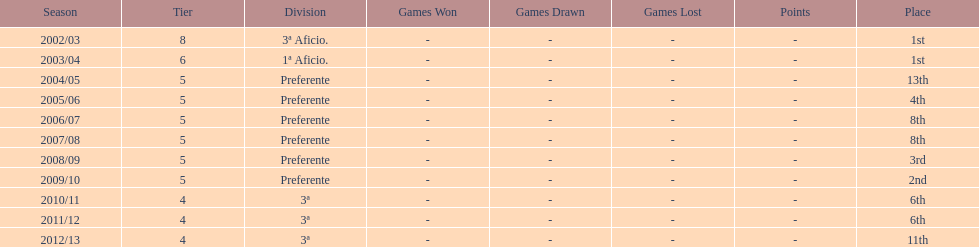Which division has the largest number of ranks? Preferente. 